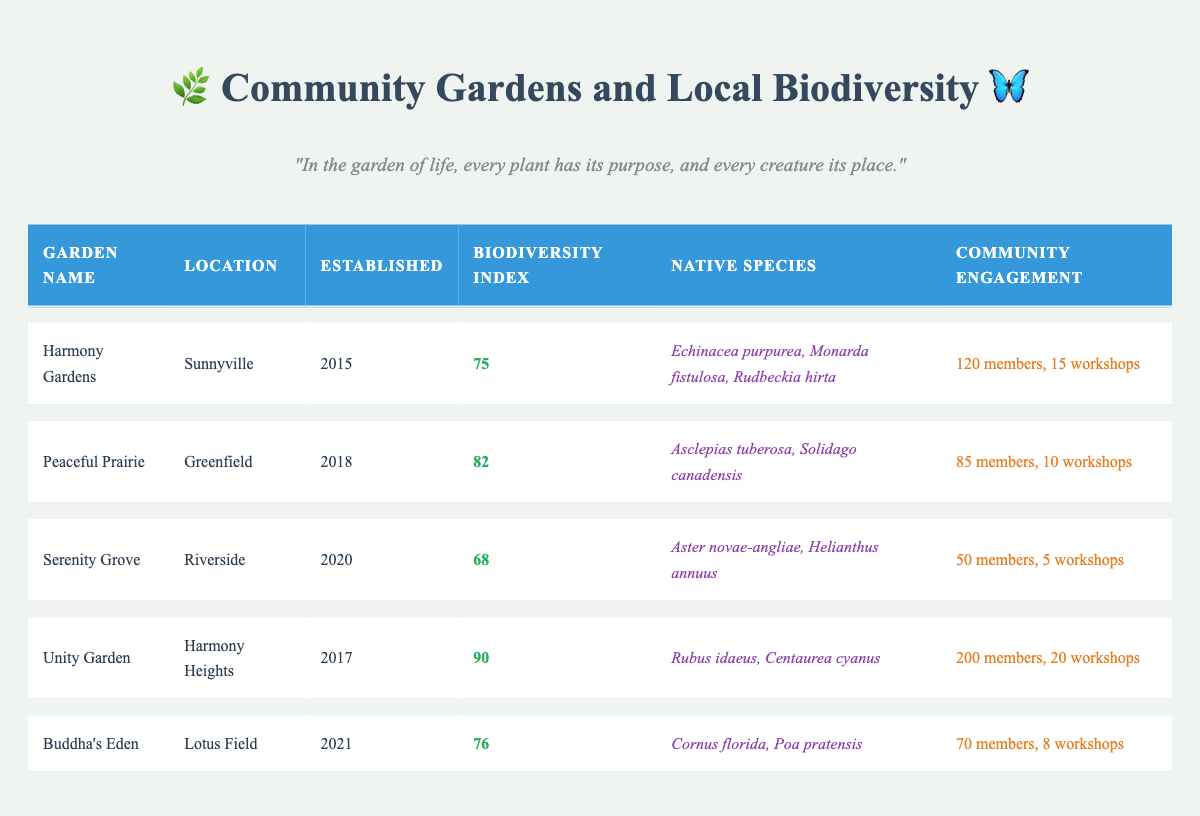What is the biodiversity index of Unity Garden? The table shows that the biodiversity index for Unity Garden is specifically listed in the index column, which states 90.
Answer: 90 How many workshops were held at Harmony Gardens? Referring to the community engagement column, it is mentioned that Harmony Gardens held 15 workshops.
Answer: 15 Which garden has the highest community engagement? By comparing the community engagement values, Unity Garden has the highest with 200 members and 20 workshops.
Answer: Unity Garden What is the average biodiversity index of all the gardens? Adding the biodiversity indices (75 + 82 + 68 + 90 + 76) results in 391. There are 5 gardens, so the average is 391/5 = 78.2.
Answer: 78.2 Are there any gardens established after 2019? Looking at the established year column, both Serenity Grove (2020) and Buddha's Eden (2021) were established after 2019. Therefore, the answer is yes.
Answer: Yes What is the difference in biodiversity index between the highest and lowest gardens? The highest biodiversity index is for Unity Garden (90) and the lowest is for Serenity Grove (68). The difference is 90 - 68 = 22.
Answer: 22 Which garden has fewer than 10 workshops held? In the table, only Serenity Grove (5 workshops) and Buddha's Eden (8 workshops) have fewer than 10 workshops held.
Answer: Serenity Grove and Buddha's Eden What is the location of the garden with the earliest establishment year? Harmony Gardens was established in 2015, which is the earliest year. Referring to the location column, it is in Sunnyville.
Answer: Sunnyville How many native species do Peaceful Prairie and Unity Garden have combined? Peaceful Prairie has 2 native species, and Unity Garden has also 2 native species. Adding them gives 2 + 2 = 4.
Answer: 4 Is there any garden with a biodiversity index below 70? Looking at the biodiversity index column, Serenity Grove has a biodiversity index of 68, confirming that there is indeed a garden with a biodiversity index below 70.
Answer: Yes 